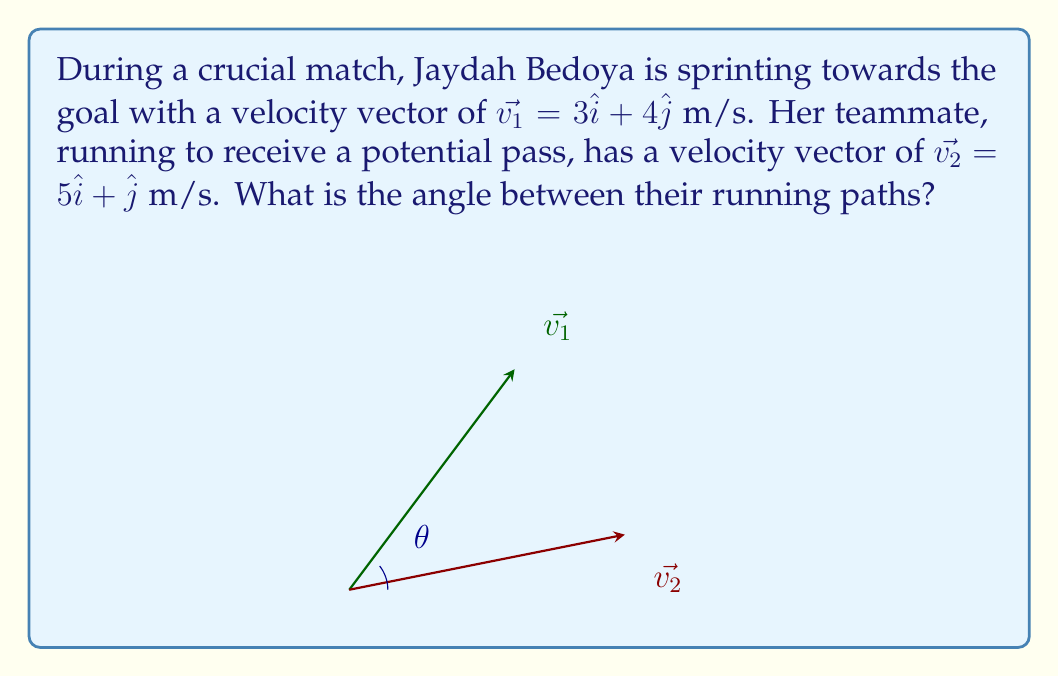Give your solution to this math problem. To find the angle between two vectors, we can use the dot product formula:

$$\cos\theta = \frac{\vec{v_1} \cdot \vec{v_2}}{|\vec{v_1}||\vec{v_2}|}$$

Step 1: Calculate the dot product $\vec{v_1} \cdot \vec{v_2}$
$$\vec{v_1} \cdot \vec{v_2} = (3)(5) + (4)(1) = 15 + 4 = 19$$

Step 2: Calculate the magnitudes of the vectors
$$|\vec{v_1}| = \sqrt{3^2 + 4^2} = \sqrt{9 + 16} = \sqrt{25} = 5$$
$$|\vec{v_2}| = \sqrt{5^2 + 1^2} = \sqrt{25 + 1} = \sqrt{26}$$

Step 3: Substitute into the formula
$$\cos\theta = \frac{19}{5\sqrt{26}}$$

Step 4: Take the inverse cosine (arccos) of both sides
$$\theta = \arccos\left(\frac{19}{5\sqrt{26}}\right)$$

Step 5: Calculate the result (approximately)
$$\theta \approx 0.5305 \text{ radians} \approx 30.4°$$
Answer: $\theta = \arccos\left(\frac{19}{5\sqrt{26}}\right) \approx 30.4°$ 